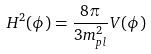<formula> <loc_0><loc_0><loc_500><loc_500>H ^ { 2 } ( \phi ) = \frac { 8 \pi } { 3 m _ { p l } ^ { 2 } } V ( \phi )</formula> 